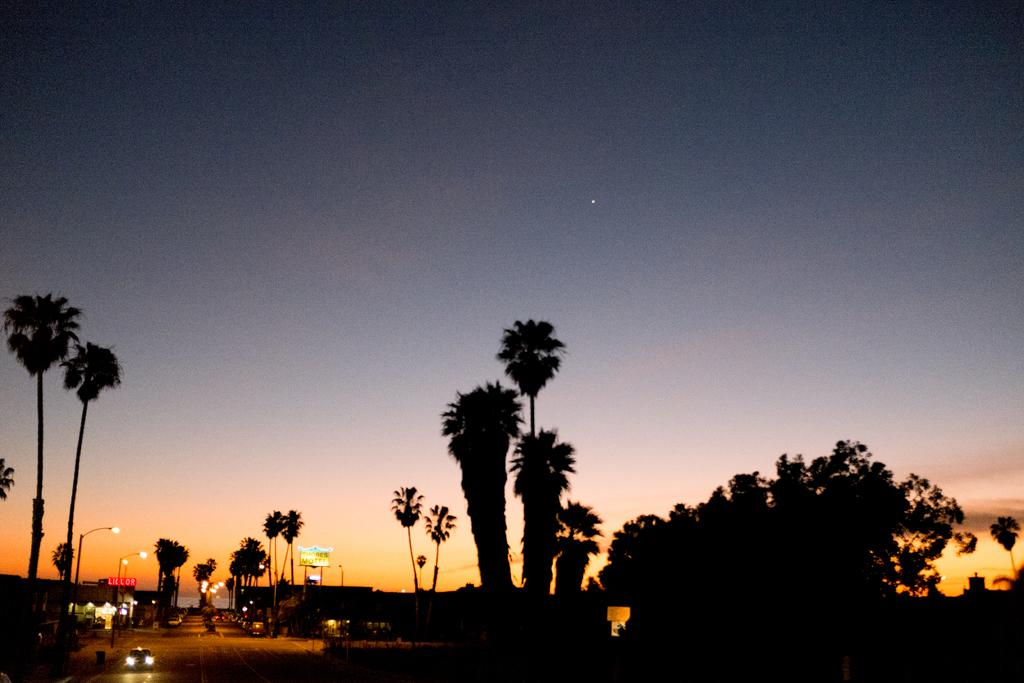What type of vegetation can be seen in the image? There are trees in the image. What is the main feature of the landscape in the image? There is a road in the image. What is moving along the road in the image? Vehicles are present on the road. What structures are present alongside the road in the image? There are light poles in the image. What is visible at the top of the image? The sky is visible at the top of the image. What type of lock is used to secure the glove in the image? There is no lock or glove present in the image. What statement is being made by the objects in the image? The image does not contain any objects that make a statement; it simply shows trees, a road, vehicles, light poles, and the sky. 